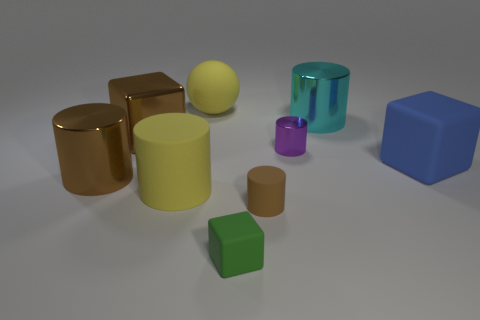What number of cylinders have the same color as the rubber ball?
Offer a very short reply. 1. Is the small cube the same color as the large rubber ball?
Give a very brief answer. No. What is the size of the yellow thing behind the big brown metal cylinder?
Give a very brief answer. Large. Is there anything else that is the same color as the large rubber cylinder?
Keep it short and to the point. Yes. Is the material of the large yellow object behind the blue matte object the same as the small block?
Provide a short and direct response. Yes. How many objects are left of the matte sphere and to the right of the large ball?
Provide a short and direct response. 0. What size is the metal cylinder behind the large block left of the tiny block?
Provide a short and direct response. Large. Is there any other thing that has the same material as the brown cube?
Provide a short and direct response. Yes. Are there more large yellow balls than yellow metallic cylinders?
Make the answer very short. Yes. Does the cylinder that is right of the tiny purple shiny cylinder have the same color as the big shiny cylinder that is to the left of the brown matte cylinder?
Your answer should be very brief. No. 